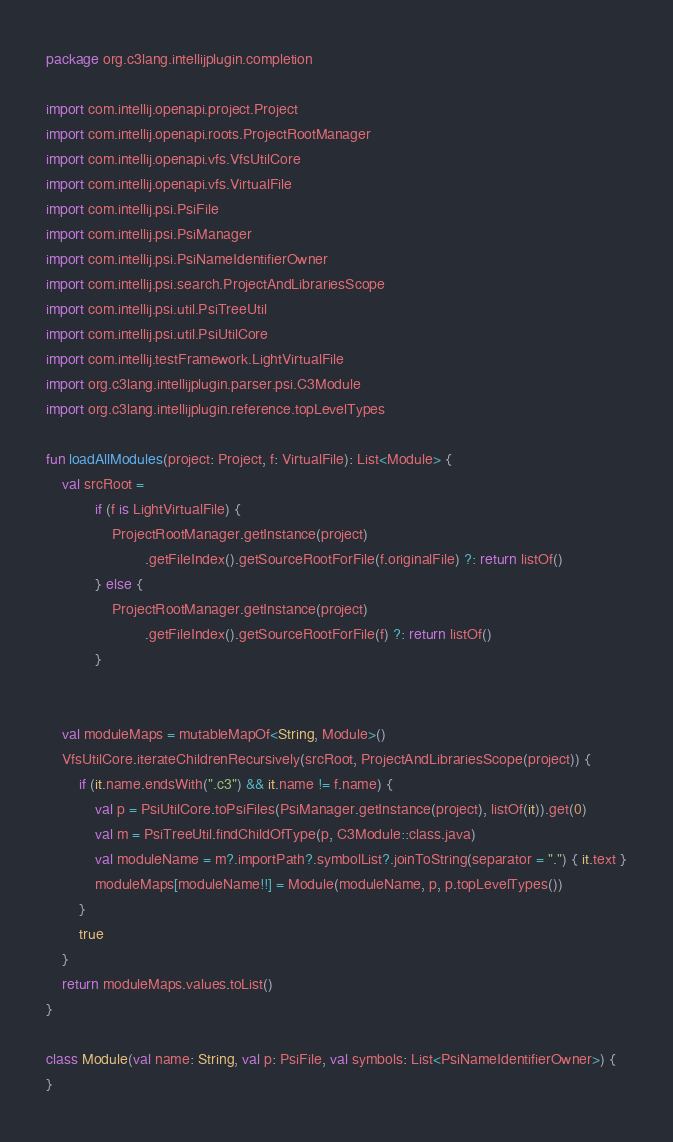<code> <loc_0><loc_0><loc_500><loc_500><_Kotlin_>package org.c3lang.intellijplugin.completion

import com.intellij.openapi.project.Project
import com.intellij.openapi.roots.ProjectRootManager
import com.intellij.openapi.vfs.VfsUtilCore
import com.intellij.openapi.vfs.VirtualFile
import com.intellij.psi.PsiFile
import com.intellij.psi.PsiManager
import com.intellij.psi.PsiNameIdentifierOwner
import com.intellij.psi.search.ProjectAndLibrariesScope
import com.intellij.psi.util.PsiTreeUtil
import com.intellij.psi.util.PsiUtilCore
import com.intellij.testFramework.LightVirtualFile
import org.c3lang.intellijplugin.parser.psi.C3Module
import org.c3lang.intellijplugin.reference.topLevelTypes

fun loadAllModules(project: Project, f: VirtualFile): List<Module> {
    val srcRoot =
            if (f is LightVirtualFile) {
                ProjectRootManager.getInstance(project)
                        .getFileIndex().getSourceRootForFile(f.originalFile) ?: return listOf()
            } else {
                ProjectRootManager.getInstance(project)
                        .getFileIndex().getSourceRootForFile(f) ?: return listOf()
            }


    val moduleMaps = mutableMapOf<String, Module>()
    VfsUtilCore.iterateChildrenRecursively(srcRoot, ProjectAndLibrariesScope(project)) {
        if (it.name.endsWith(".c3") && it.name != f.name) {
            val p = PsiUtilCore.toPsiFiles(PsiManager.getInstance(project), listOf(it)).get(0)
            val m = PsiTreeUtil.findChildOfType(p, C3Module::class.java)
            val moduleName = m?.importPath?.symbolList?.joinToString(separator = ".") { it.text }
            moduleMaps[moduleName!!] = Module(moduleName, p, p.topLevelTypes())
        }
        true
    }
    return moduleMaps.values.toList()
}

class Module(val name: String, val p: PsiFile, val symbols: List<PsiNameIdentifierOwner>) {
}</code> 